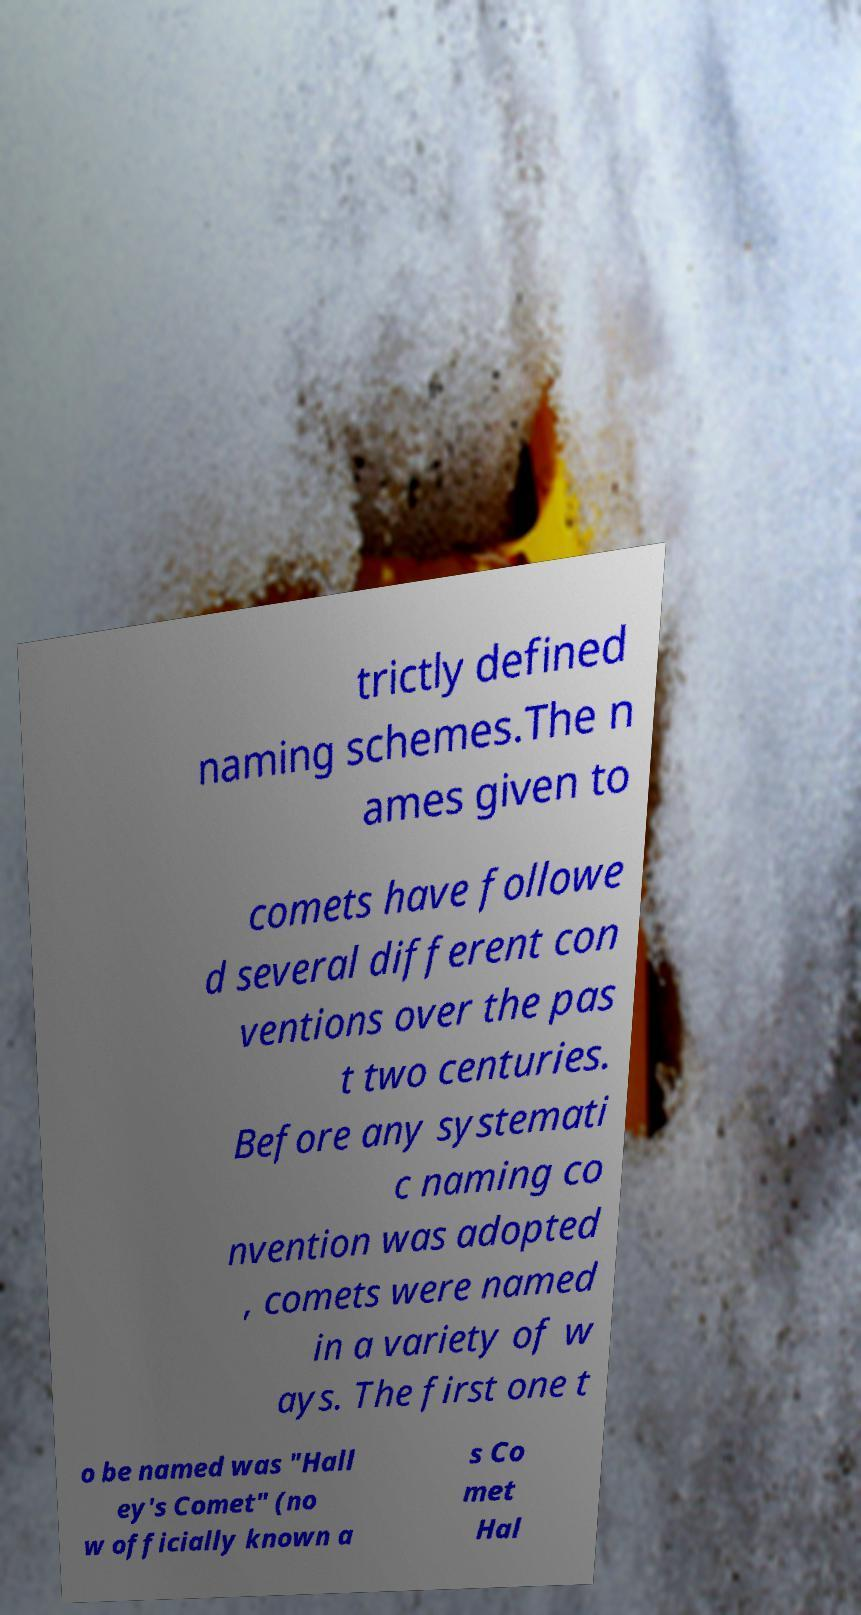For documentation purposes, I need the text within this image transcribed. Could you provide that? trictly defined naming schemes.The n ames given to comets have followe d several different con ventions over the pas t two centuries. Before any systemati c naming co nvention was adopted , comets were named in a variety of w ays. The first one t o be named was "Hall ey's Comet" (no w officially known a s Co met Hal 